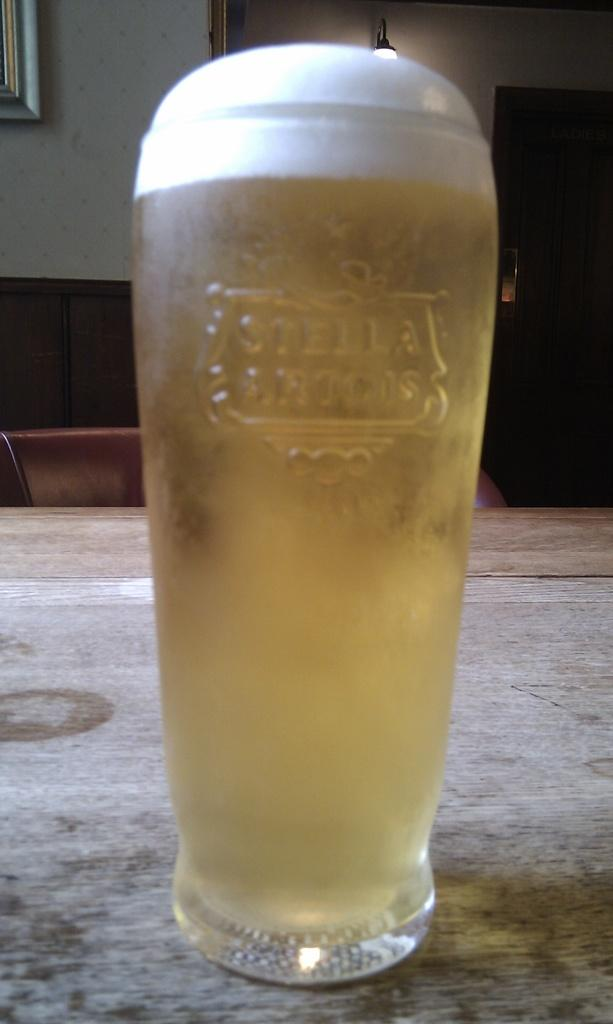What type of table is in the image? There is a wooden table in the image. What is on the table? There is beer in a glass on the table. What can be seen in the background of the image? There are chairs, a closet, a frame, a wall, and a lamp in the background of the image. What is the price of the plastic trucks in the image? There are no plastic trucks present in the image. 